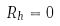Convert formula to latex. <formula><loc_0><loc_0><loc_500><loc_500>R _ { h } = 0</formula> 